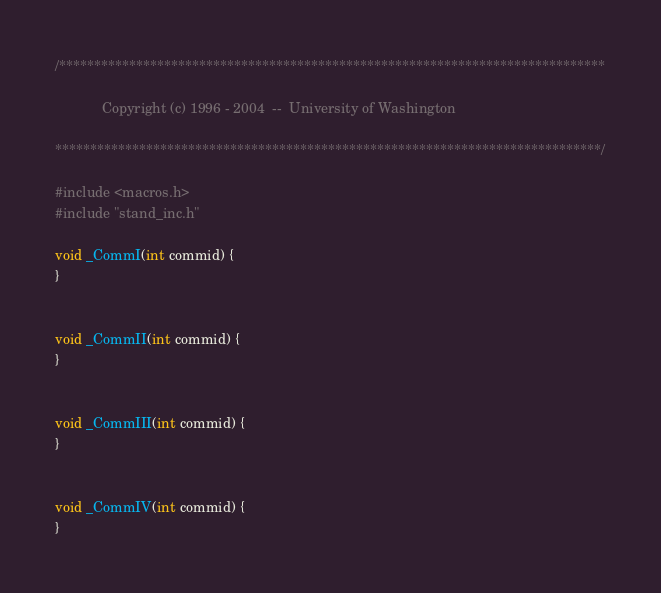<code> <loc_0><loc_0><loc_500><loc_500><_C_>/******************************************************************************

            Copyright (c) 1996 - 2004  --  University of Washington

******************************************************************************/

#include <macros.h>
#include "stand_inc.h"

void _CommI(int commid) {
}


void _CommII(int commid) {
}


void _CommIII(int commid) {
}


void _CommIV(int commid) {
}
</code> 